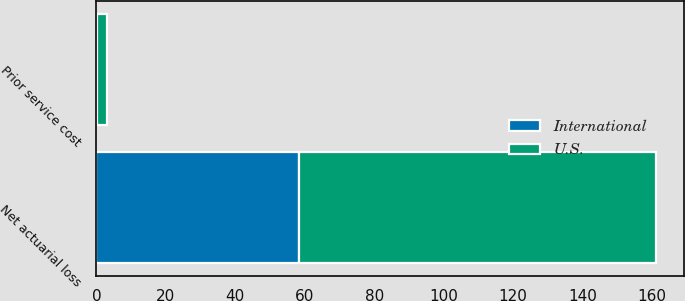Convert chart. <chart><loc_0><loc_0><loc_500><loc_500><stacked_bar_chart><ecel><fcel>Net actuarial loss<fcel>Prior service cost<nl><fcel>U.S.<fcel>103<fcel>2.8<nl><fcel>International<fcel>58.3<fcel>0.2<nl></chart> 